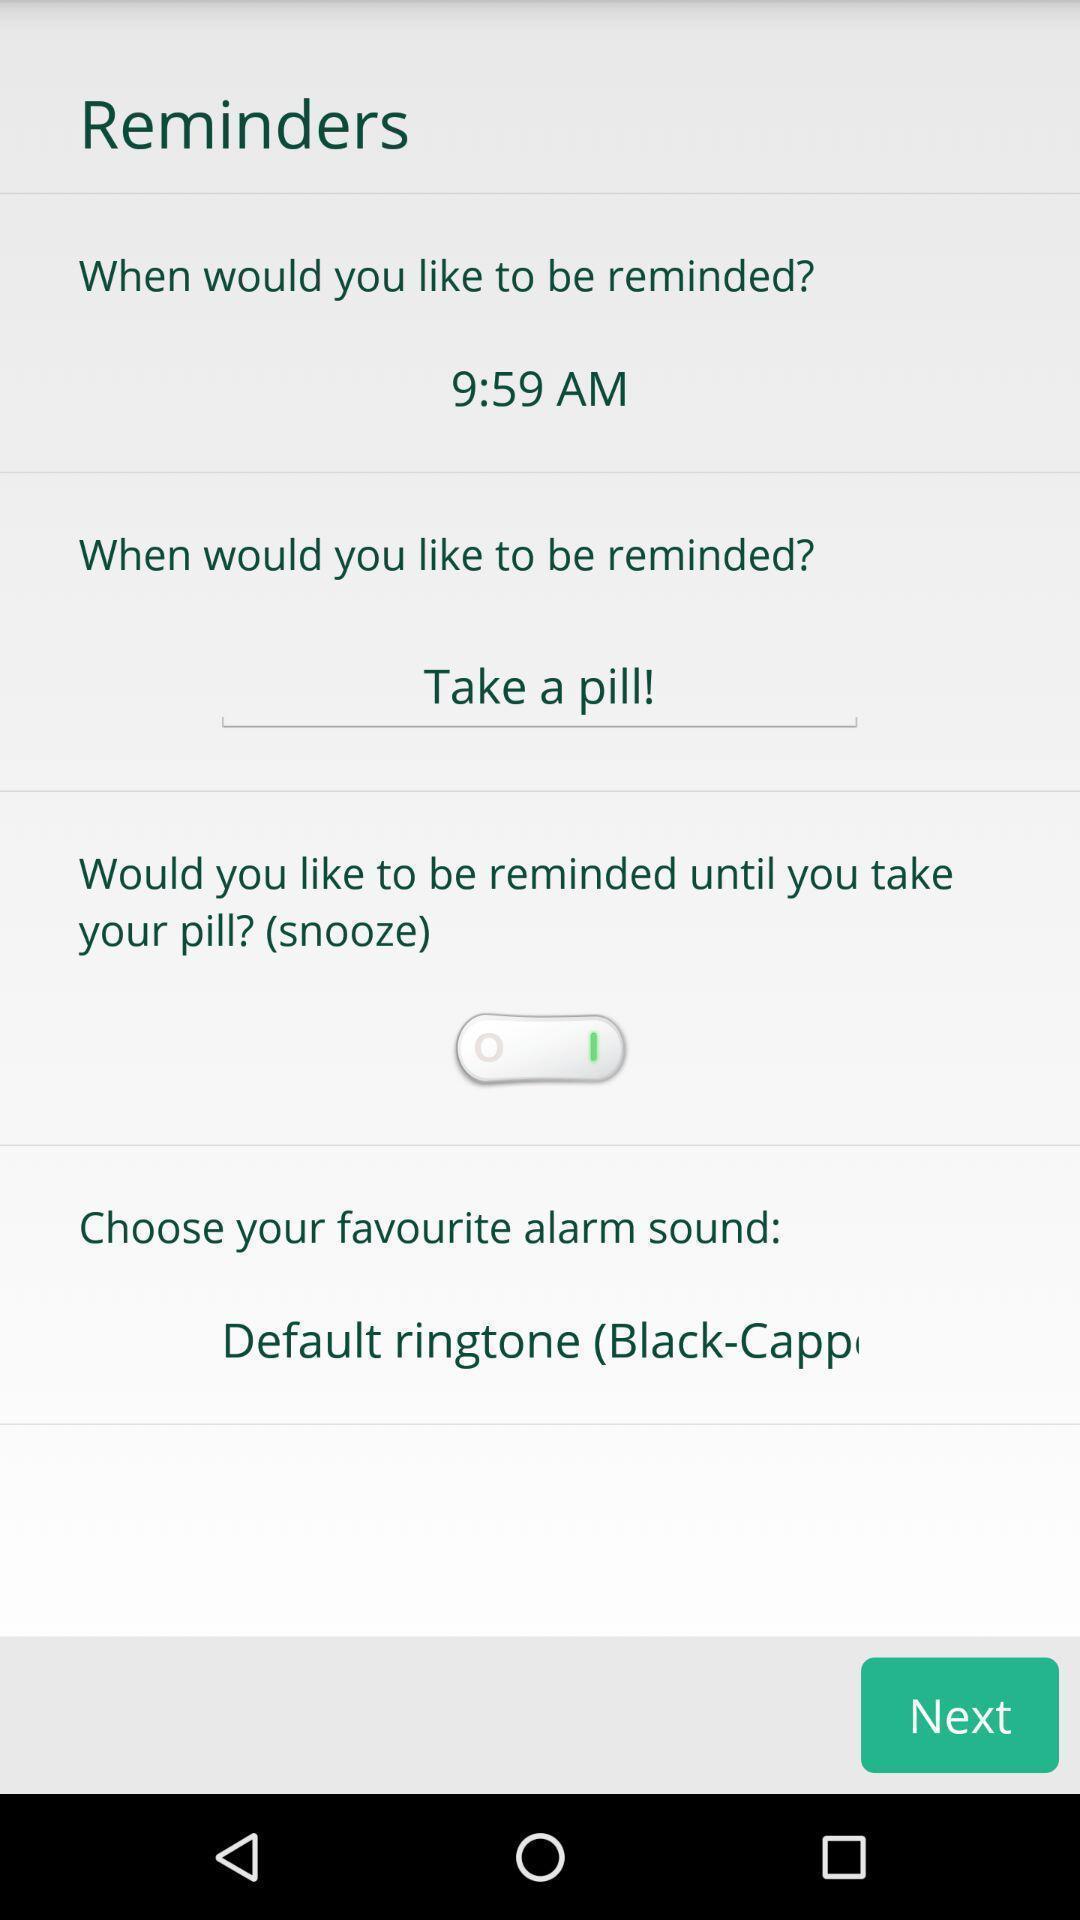What details can you identify in this image? Screen displaying about reminders settings. 